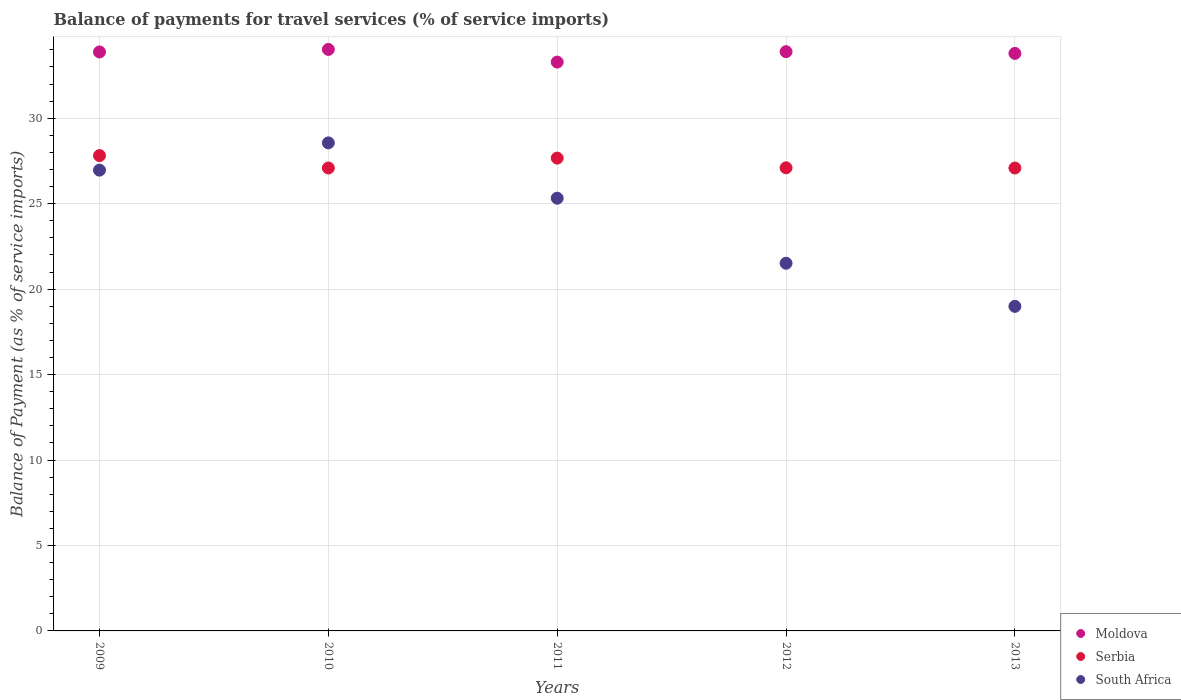Is the number of dotlines equal to the number of legend labels?
Offer a very short reply. Yes. What is the balance of payments for travel services in Serbia in 2009?
Your answer should be compact. 27.81. Across all years, what is the maximum balance of payments for travel services in Serbia?
Your response must be concise. 27.81. Across all years, what is the minimum balance of payments for travel services in Moldova?
Your answer should be very brief. 33.28. In which year was the balance of payments for travel services in Serbia maximum?
Give a very brief answer. 2009. What is the total balance of payments for travel services in Serbia in the graph?
Offer a very short reply. 136.75. What is the difference between the balance of payments for travel services in Moldova in 2009 and that in 2010?
Make the answer very short. -0.15. What is the difference between the balance of payments for travel services in Serbia in 2013 and the balance of payments for travel services in Moldova in 2009?
Your answer should be compact. -6.79. What is the average balance of payments for travel services in Moldova per year?
Offer a very short reply. 33.77. In the year 2009, what is the difference between the balance of payments for travel services in Serbia and balance of payments for travel services in South Africa?
Your answer should be very brief. 0.85. What is the ratio of the balance of payments for travel services in Moldova in 2010 to that in 2013?
Provide a short and direct response. 1.01. Is the difference between the balance of payments for travel services in Serbia in 2009 and 2010 greater than the difference between the balance of payments for travel services in South Africa in 2009 and 2010?
Make the answer very short. Yes. What is the difference between the highest and the second highest balance of payments for travel services in South Africa?
Your answer should be compact. 1.59. What is the difference between the highest and the lowest balance of payments for travel services in Serbia?
Provide a succinct answer. 0.73. In how many years, is the balance of payments for travel services in Serbia greater than the average balance of payments for travel services in Serbia taken over all years?
Ensure brevity in your answer.  2. Is the sum of the balance of payments for travel services in Serbia in 2009 and 2012 greater than the maximum balance of payments for travel services in Moldova across all years?
Keep it short and to the point. Yes. Is it the case that in every year, the sum of the balance of payments for travel services in Serbia and balance of payments for travel services in Moldova  is greater than the balance of payments for travel services in South Africa?
Offer a terse response. Yes. Is the balance of payments for travel services in Moldova strictly greater than the balance of payments for travel services in South Africa over the years?
Ensure brevity in your answer.  Yes. Does the graph contain any zero values?
Provide a short and direct response. No. How many legend labels are there?
Your answer should be very brief. 3. What is the title of the graph?
Keep it short and to the point. Balance of payments for travel services (% of service imports). What is the label or title of the X-axis?
Keep it short and to the point. Years. What is the label or title of the Y-axis?
Your answer should be compact. Balance of Payment (as % of service imports). What is the Balance of Payment (as % of service imports) in Moldova in 2009?
Your answer should be compact. 33.88. What is the Balance of Payment (as % of service imports) of Serbia in 2009?
Your answer should be very brief. 27.81. What is the Balance of Payment (as % of service imports) in South Africa in 2009?
Make the answer very short. 26.96. What is the Balance of Payment (as % of service imports) of Moldova in 2010?
Ensure brevity in your answer.  34.03. What is the Balance of Payment (as % of service imports) of Serbia in 2010?
Provide a short and direct response. 27.09. What is the Balance of Payment (as % of service imports) in South Africa in 2010?
Ensure brevity in your answer.  28.56. What is the Balance of Payment (as % of service imports) in Moldova in 2011?
Your answer should be compact. 33.28. What is the Balance of Payment (as % of service imports) in Serbia in 2011?
Provide a short and direct response. 27.67. What is the Balance of Payment (as % of service imports) of South Africa in 2011?
Give a very brief answer. 25.32. What is the Balance of Payment (as % of service imports) of Moldova in 2012?
Offer a terse response. 33.89. What is the Balance of Payment (as % of service imports) in Serbia in 2012?
Keep it short and to the point. 27.1. What is the Balance of Payment (as % of service imports) of South Africa in 2012?
Offer a very short reply. 21.51. What is the Balance of Payment (as % of service imports) in Moldova in 2013?
Give a very brief answer. 33.79. What is the Balance of Payment (as % of service imports) in Serbia in 2013?
Ensure brevity in your answer.  27.09. What is the Balance of Payment (as % of service imports) of South Africa in 2013?
Keep it short and to the point. 18.99. Across all years, what is the maximum Balance of Payment (as % of service imports) in Moldova?
Give a very brief answer. 34.03. Across all years, what is the maximum Balance of Payment (as % of service imports) of Serbia?
Your answer should be compact. 27.81. Across all years, what is the maximum Balance of Payment (as % of service imports) of South Africa?
Make the answer very short. 28.56. Across all years, what is the minimum Balance of Payment (as % of service imports) in Moldova?
Give a very brief answer. 33.28. Across all years, what is the minimum Balance of Payment (as % of service imports) in Serbia?
Offer a very short reply. 27.09. Across all years, what is the minimum Balance of Payment (as % of service imports) in South Africa?
Your response must be concise. 18.99. What is the total Balance of Payment (as % of service imports) in Moldova in the graph?
Provide a succinct answer. 168.87. What is the total Balance of Payment (as % of service imports) in Serbia in the graph?
Make the answer very short. 136.75. What is the total Balance of Payment (as % of service imports) in South Africa in the graph?
Offer a very short reply. 121.34. What is the difference between the Balance of Payment (as % of service imports) in Moldova in 2009 and that in 2010?
Your answer should be very brief. -0.15. What is the difference between the Balance of Payment (as % of service imports) in Serbia in 2009 and that in 2010?
Offer a very short reply. 0.73. What is the difference between the Balance of Payment (as % of service imports) in South Africa in 2009 and that in 2010?
Make the answer very short. -1.59. What is the difference between the Balance of Payment (as % of service imports) of Moldova in 2009 and that in 2011?
Your response must be concise. 0.59. What is the difference between the Balance of Payment (as % of service imports) in Serbia in 2009 and that in 2011?
Your answer should be very brief. 0.15. What is the difference between the Balance of Payment (as % of service imports) in South Africa in 2009 and that in 2011?
Make the answer very short. 1.64. What is the difference between the Balance of Payment (as % of service imports) of Moldova in 2009 and that in 2012?
Make the answer very short. -0.02. What is the difference between the Balance of Payment (as % of service imports) of Serbia in 2009 and that in 2012?
Give a very brief answer. 0.71. What is the difference between the Balance of Payment (as % of service imports) in South Africa in 2009 and that in 2012?
Give a very brief answer. 5.45. What is the difference between the Balance of Payment (as % of service imports) of Moldova in 2009 and that in 2013?
Provide a short and direct response. 0.09. What is the difference between the Balance of Payment (as % of service imports) of Serbia in 2009 and that in 2013?
Your answer should be compact. 0.73. What is the difference between the Balance of Payment (as % of service imports) in South Africa in 2009 and that in 2013?
Provide a succinct answer. 7.97. What is the difference between the Balance of Payment (as % of service imports) of Moldova in 2010 and that in 2011?
Offer a terse response. 0.74. What is the difference between the Balance of Payment (as % of service imports) in Serbia in 2010 and that in 2011?
Your answer should be compact. -0.58. What is the difference between the Balance of Payment (as % of service imports) of South Africa in 2010 and that in 2011?
Offer a terse response. 3.24. What is the difference between the Balance of Payment (as % of service imports) of Moldova in 2010 and that in 2012?
Provide a short and direct response. 0.13. What is the difference between the Balance of Payment (as % of service imports) of Serbia in 2010 and that in 2012?
Make the answer very short. -0.01. What is the difference between the Balance of Payment (as % of service imports) in South Africa in 2010 and that in 2012?
Keep it short and to the point. 7.04. What is the difference between the Balance of Payment (as % of service imports) of Moldova in 2010 and that in 2013?
Offer a terse response. 0.23. What is the difference between the Balance of Payment (as % of service imports) in Serbia in 2010 and that in 2013?
Make the answer very short. 0. What is the difference between the Balance of Payment (as % of service imports) in South Africa in 2010 and that in 2013?
Provide a succinct answer. 9.57. What is the difference between the Balance of Payment (as % of service imports) of Moldova in 2011 and that in 2012?
Make the answer very short. -0.61. What is the difference between the Balance of Payment (as % of service imports) in Serbia in 2011 and that in 2012?
Offer a very short reply. 0.57. What is the difference between the Balance of Payment (as % of service imports) of South Africa in 2011 and that in 2012?
Make the answer very short. 3.81. What is the difference between the Balance of Payment (as % of service imports) in Moldova in 2011 and that in 2013?
Your response must be concise. -0.51. What is the difference between the Balance of Payment (as % of service imports) of Serbia in 2011 and that in 2013?
Keep it short and to the point. 0.58. What is the difference between the Balance of Payment (as % of service imports) of South Africa in 2011 and that in 2013?
Your answer should be very brief. 6.33. What is the difference between the Balance of Payment (as % of service imports) in Moldova in 2012 and that in 2013?
Ensure brevity in your answer.  0.1. What is the difference between the Balance of Payment (as % of service imports) in Serbia in 2012 and that in 2013?
Offer a very short reply. 0.01. What is the difference between the Balance of Payment (as % of service imports) of South Africa in 2012 and that in 2013?
Provide a short and direct response. 2.52. What is the difference between the Balance of Payment (as % of service imports) in Moldova in 2009 and the Balance of Payment (as % of service imports) in Serbia in 2010?
Keep it short and to the point. 6.79. What is the difference between the Balance of Payment (as % of service imports) in Moldova in 2009 and the Balance of Payment (as % of service imports) in South Africa in 2010?
Ensure brevity in your answer.  5.32. What is the difference between the Balance of Payment (as % of service imports) in Serbia in 2009 and the Balance of Payment (as % of service imports) in South Africa in 2010?
Provide a succinct answer. -0.74. What is the difference between the Balance of Payment (as % of service imports) in Moldova in 2009 and the Balance of Payment (as % of service imports) in Serbia in 2011?
Keep it short and to the point. 6.21. What is the difference between the Balance of Payment (as % of service imports) in Moldova in 2009 and the Balance of Payment (as % of service imports) in South Africa in 2011?
Your answer should be very brief. 8.56. What is the difference between the Balance of Payment (as % of service imports) of Serbia in 2009 and the Balance of Payment (as % of service imports) of South Africa in 2011?
Your response must be concise. 2.49. What is the difference between the Balance of Payment (as % of service imports) of Moldova in 2009 and the Balance of Payment (as % of service imports) of Serbia in 2012?
Your answer should be very brief. 6.78. What is the difference between the Balance of Payment (as % of service imports) of Moldova in 2009 and the Balance of Payment (as % of service imports) of South Africa in 2012?
Your answer should be very brief. 12.36. What is the difference between the Balance of Payment (as % of service imports) of Serbia in 2009 and the Balance of Payment (as % of service imports) of South Africa in 2012?
Provide a short and direct response. 6.3. What is the difference between the Balance of Payment (as % of service imports) in Moldova in 2009 and the Balance of Payment (as % of service imports) in Serbia in 2013?
Your response must be concise. 6.79. What is the difference between the Balance of Payment (as % of service imports) in Moldova in 2009 and the Balance of Payment (as % of service imports) in South Africa in 2013?
Offer a very short reply. 14.89. What is the difference between the Balance of Payment (as % of service imports) of Serbia in 2009 and the Balance of Payment (as % of service imports) of South Africa in 2013?
Provide a short and direct response. 8.82. What is the difference between the Balance of Payment (as % of service imports) of Moldova in 2010 and the Balance of Payment (as % of service imports) of Serbia in 2011?
Offer a very short reply. 6.36. What is the difference between the Balance of Payment (as % of service imports) of Moldova in 2010 and the Balance of Payment (as % of service imports) of South Africa in 2011?
Offer a very short reply. 8.71. What is the difference between the Balance of Payment (as % of service imports) in Serbia in 2010 and the Balance of Payment (as % of service imports) in South Africa in 2011?
Keep it short and to the point. 1.77. What is the difference between the Balance of Payment (as % of service imports) of Moldova in 2010 and the Balance of Payment (as % of service imports) of Serbia in 2012?
Offer a very short reply. 6.93. What is the difference between the Balance of Payment (as % of service imports) in Moldova in 2010 and the Balance of Payment (as % of service imports) in South Africa in 2012?
Keep it short and to the point. 12.51. What is the difference between the Balance of Payment (as % of service imports) of Serbia in 2010 and the Balance of Payment (as % of service imports) of South Africa in 2012?
Offer a very short reply. 5.57. What is the difference between the Balance of Payment (as % of service imports) of Moldova in 2010 and the Balance of Payment (as % of service imports) of Serbia in 2013?
Offer a terse response. 6.94. What is the difference between the Balance of Payment (as % of service imports) in Moldova in 2010 and the Balance of Payment (as % of service imports) in South Africa in 2013?
Your answer should be compact. 15.03. What is the difference between the Balance of Payment (as % of service imports) of Serbia in 2010 and the Balance of Payment (as % of service imports) of South Africa in 2013?
Provide a succinct answer. 8.1. What is the difference between the Balance of Payment (as % of service imports) of Moldova in 2011 and the Balance of Payment (as % of service imports) of Serbia in 2012?
Your answer should be compact. 6.19. What is the difference between the Balance of Payment (as % of service imports) in Moldova in 2011 and the Balance of Payment (as % of service imports) in South Africa in 2012?
Provide a succinct answer. 11.77. What is the difference between the Balance of Payment (as % of service imports) of Serbia in 2011 and the Balance of Payment (as % of service imports) of South Africa in 2012?
Make the answer very short. 6.15. What is the difference between the Balance of Payment (as % of service imports) in Moldova in 2011 and the Balance of Payment (as % of service imports) in Serbia in 2013?
Offer a terse response. 6.2. What is the difference between the Balance of Payment (as % of service imports) in Moldova in 2011 and the Balance of Payment (as % of service imports) in South Africa in 2013?
Give a very brief answer. 14.29. What is the difference between the Balance of Payment (as % of service imports) of Serbia in 2011 and the Balance of Payment (as % of service imports) of South Africa in 2013?
Ensure brevity in your answer.  8.67. What is the difference between the Balance of Payment (as % of service imports) of Moldova in 2012 and the Balance of Payment (as % of service imports) of Serbia in 2013?
Your answer should be very brief. 6.81. What is the difference between the Balance of Payment (as % of service imports) of Moldova in 2012 and the Balance of Payment (as % of service imports) of South Africa in 2013?
Provide a short and direct response. 14.9. What is the difference between the Balance of Payment (as % of service imports) of Serbia in 2012 and the Balance of Payment (as % of service imports) of South Africa in 2013?
Provide a succinct answer. 8.11. What is the average Balance of Payment (as % of service imports) of Moldova per year?
Offer a terse response. 33.77. What is the average Balance of Payment (as % of service imports) in Serbia per year?
Your answer should be very brief. 27.35. What is the average Balance of Payment (as % of service imports) of South Africa per year?
Ensure brevity in your answer.  24.27. In the year 2009, what is the difference between the Balance of Payment (as % of service imports) of Moldova and Balance of Payment (as % of service imports) of Serbia?
Provide a short and direct response. 6.06. In the year 2009, what is the difference between the Balance of Payment (as % of service imports) in Moldova and Balance of Payment (as % of service imports) in South Africa?
Your answer should be compact. 6.92. In the year 2009, what is the difference between the Balance of Payment (as % of service imports) of Serbia and Balance of Payment (as % of service imports) of South Africa?
Keep it short and to the point. 0.85. In the year 2010, what is the difference between the Balance of Payment (as % of service imports) in Moldova and Balance of Payment (as % of service imports) in Serbia?
Your response must be concise. 6.94. In the year 2010, what is the difference between the Balance of Payment (as % of service imports) of Moldova and Balance of Payment (as % of service imports) of South Africa?
Offer a very short reply. 5.47. In the year 2010, what is the difference between the Balance of Payment (as % of service imports) of Serbia and Balance of Payment (as % of service imports) of South Africa?
Keep it short and to the point. -1.47. In the year 2011, what is the difference between the Balance of Payment (as % of service imports) in Moldova and Balance of Payment (as % of service imports) in Serbia?
Your response must be concise. 5.62. In the year 2011, what is the difference between the Balance of Payment (as % of service imports) in Moldova and Balance of Payment (as % of service imports) in South Africa?
Provide a succinct answer. 7.96. In the year 2011, what is the difference between the Balance of Payment (as % of service imports) in Serbia and Balance of Payment (as % of service imports) in South Africa?
Keep it short and to the point. 2.35. In the year 2012, what is the difference between the Balance of Payment (as % of service imports) of Moldova and Balance of Payment (as % of service imports) of Serbia?
Ensure brevity in your answer.  6.79. In the year 2012, what is the difference between the Balance of Payment (as % of service imports) in Moldova and Balance of Payment (as % of service imports) in South Africa?
Your answer should be very brief. 12.38. In the year 2012, what is the difference between the Balance of Payment (as % of service imports) of Serbia and Balance of Payment (as % of service imports) of South Africa?
Provide a short and direct response. 5.59. In the year 2013, what is the difference between the Balance of Payment (as % of service imports) of Moldova and Balance of Payment (as % of service imports) of Serbia?
Provide a succinct answer. 6.71. In the year 2013, what is the difference between the Balance of Payment (as % of service imports) in Moldova and Balance of Payment (as % of service imports) in South Africa?
Your response must be concise. 14.8. In the year 2013, what is the difference between the Balance of Payment (as % of service imports) of Serbia and Balance of Payment (as % of service imports) of South Africa?
Provide a short and direct response. 8.09. What is the ratio of the Balance of Payment (as % of service imports) in Serbia in 2009 to that in 2010?
Provide a short and direct response. 1.03. What is the ratio of the Balance of Payment (as % of service imports) of South Africa in 2009 to that in 2010?
Offer a terse response. 0.94. What is the ratio of the Balance of Payment (as % of service imports) of Moldova in 2009 to that in 2011?
Offer a terse response. 1.02. What is the ratio of the Balance of Payment (as % of service imports) in South Africa in 2009 to that in 2011?
Make the answer very short. 1.06. What is the ratio of the Balance of Payment (as % of service imports) in Moldova in 2009 to that in 2012?
Ensure brevity in your answer.  1. What is the ratio of the Balance of Payment (as % of service imports) in Serbia in 2009 to that in 2012?
Provide a succinct answer. 1.03. What is the ratio of the Balance of Payment (as % of service imports) in South Africa in 2009 to that in 2012?
Offer a very short reply. 1.25. What is the ratio of the Balance of Payment (as % of service imports) in Moldova in 2009 to that in 2013?
Give a very brief answer. 1. What is the ratio of the Balance of Payment (as % of service imports) in Serbia in 2009 to that in 2013?
Give a very brief answer. 1.03. What is the ratio of the Balance of Payment (as % of service imports) in South Africa in 2009 to that in 2013?
Provide a short and direct response. 1.42. What is the ratio of the Balance of Payment (as % of service imports) of Moldova in 2010 to that in 2011?
Provide a succinct answer. 1.02. What is the ratio of the Balance of Payment (as % of service imports) of Serbia in 2010 to that in 2011?
Offer a very short reply. 0.98. What is the ratio of the Balance of Payment (as % of service imports) in South Africa in 2010 to that in 2011?
Give a very brief answer. 1.13. What is the ratio of the Balance of Payment (as % of service imports) of Moldova in 2010 to that in 2012?
Your answer should be very brief. 1. What is the ratio of the Balance of Payment (as % of service imports) of South Africa in 2010 to that in 2012?
Keep it short and to the point. 1.33. What is the ratio of the Balance of Payment (as % of service imports) of Moldova in 2010 to that in 2013?
Your response must be concise. 1.01. What is the ratio of the Balance of Payment (as % of service imports) of Serbia in 2010 to that in 2013?
Offer a very short reply. 1. What is the ratio of the Balance of Payment (as % of service imports) of South Africa in 2010 to that in 2013?
Your answer should be compact. 1.5. What is the ratio of the Balance of Payment (as % of service imports) in Serbia in 2011 to that in 2012?
Offer a very short reply. 1.02. What is the ratio of the Balance of Payment (as % of service imports) of South Africa in 2011 to that in 2012?
Your answer should be very brief. 1.18. What is the ratio of the Balance of Payment (as % of service imports) in Moldova in 2011 to that in 2013?
Offer a very short reply. 0.98. What is the ratio of the Balance of Payment (as % of service imports) of Serbia in 2011 to that in 2013?
Your answer should be compact. 1.02. What is the ratio of the Balance of Payment (as % of service imports) of South Africa in 2011 to that in 2013?
Your answer should be very brief. 1.33. What is the ratio of the Balance of Payment (as % of service imports) in Moldova in 2012 to that in 2013?
Your answer should be very brief. 1. What is the ratio of the Balance of Payment (as % of service imports) of South Africa in 2012 to that in 2013?
Provide a short and direct response. 1.13. What is the difference between the highest and the second highest Balance of Payment (as % of service imports) of Moldova?
Your answer should be very brief. 0.13. What is the difference between the highest and the second highest Balance of Payment (as % of service imports) of Serbia?
Give a very brief answer. 0.15. What is the difference between the highest and the second highest Balance of Payment (as % of service imports) of South Africa?
Keep it short and to the point. 1.59. What is the difference between the highest and the lowest Balance of Payment (as % of service imports) of Moldova?
Offer a very short reply. 0.74. What is the difference between the highest and the lowest Balance of Payment (as % of service imports) in Serbia?
Give a very brief answer. 0.73. What is the difference between the highest and the lowest Balance of Payment (as % of service imports) in South Africa?
Make the answer very short. 9.57. 